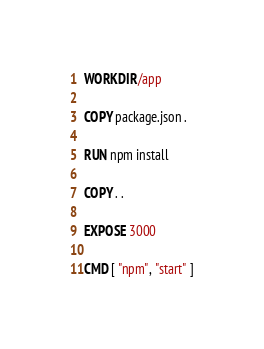<code> <loc_0><loc_0><loc_500><loc_500><_Dockerfile_>
WORKDIR /app

COPY package.json .

RUN npm install

COPY . .

EXPOSE 3000

CMD [ "npm", "start" ]</code> 